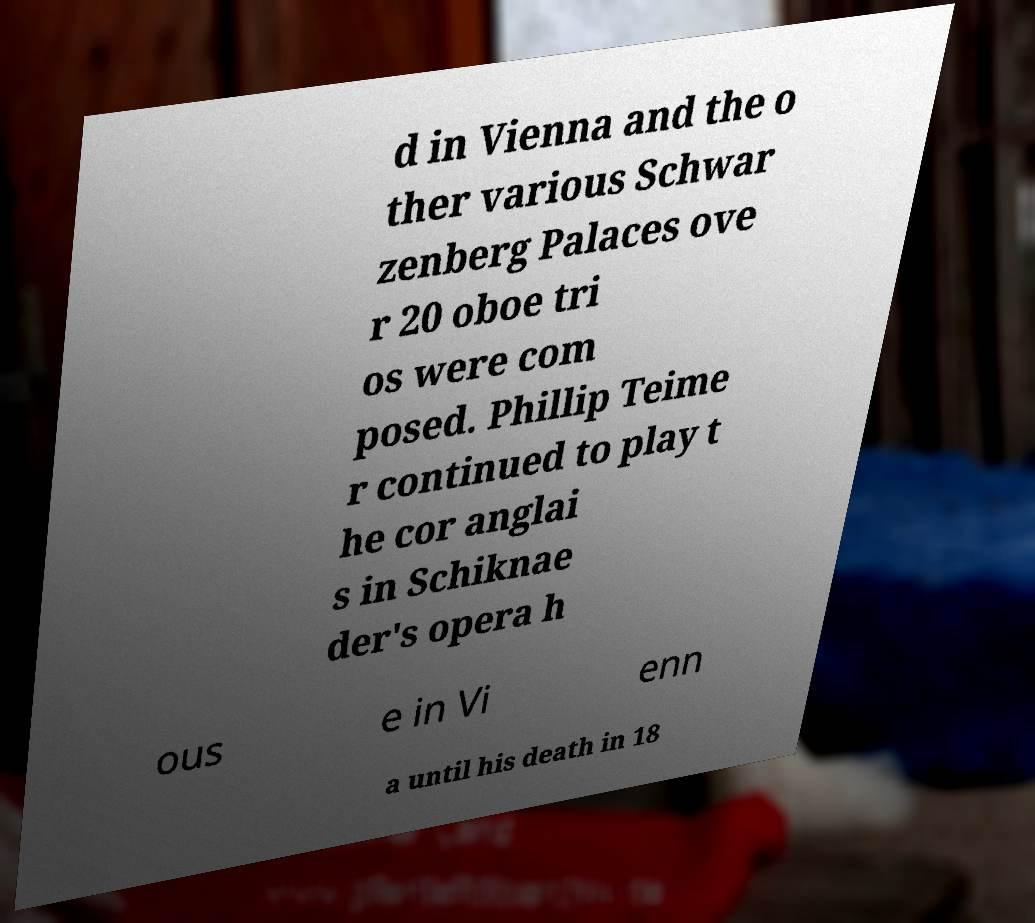Could you extract and type out the text from this image? d in Vienna and the o ther various Schwar zenberg Palaces ove r 20 oboe tri os were com posed. Phillip Teime r continued to play t he cor anglai s in Schiknae der's opera h ous e in Vi enn a until his death in 18 